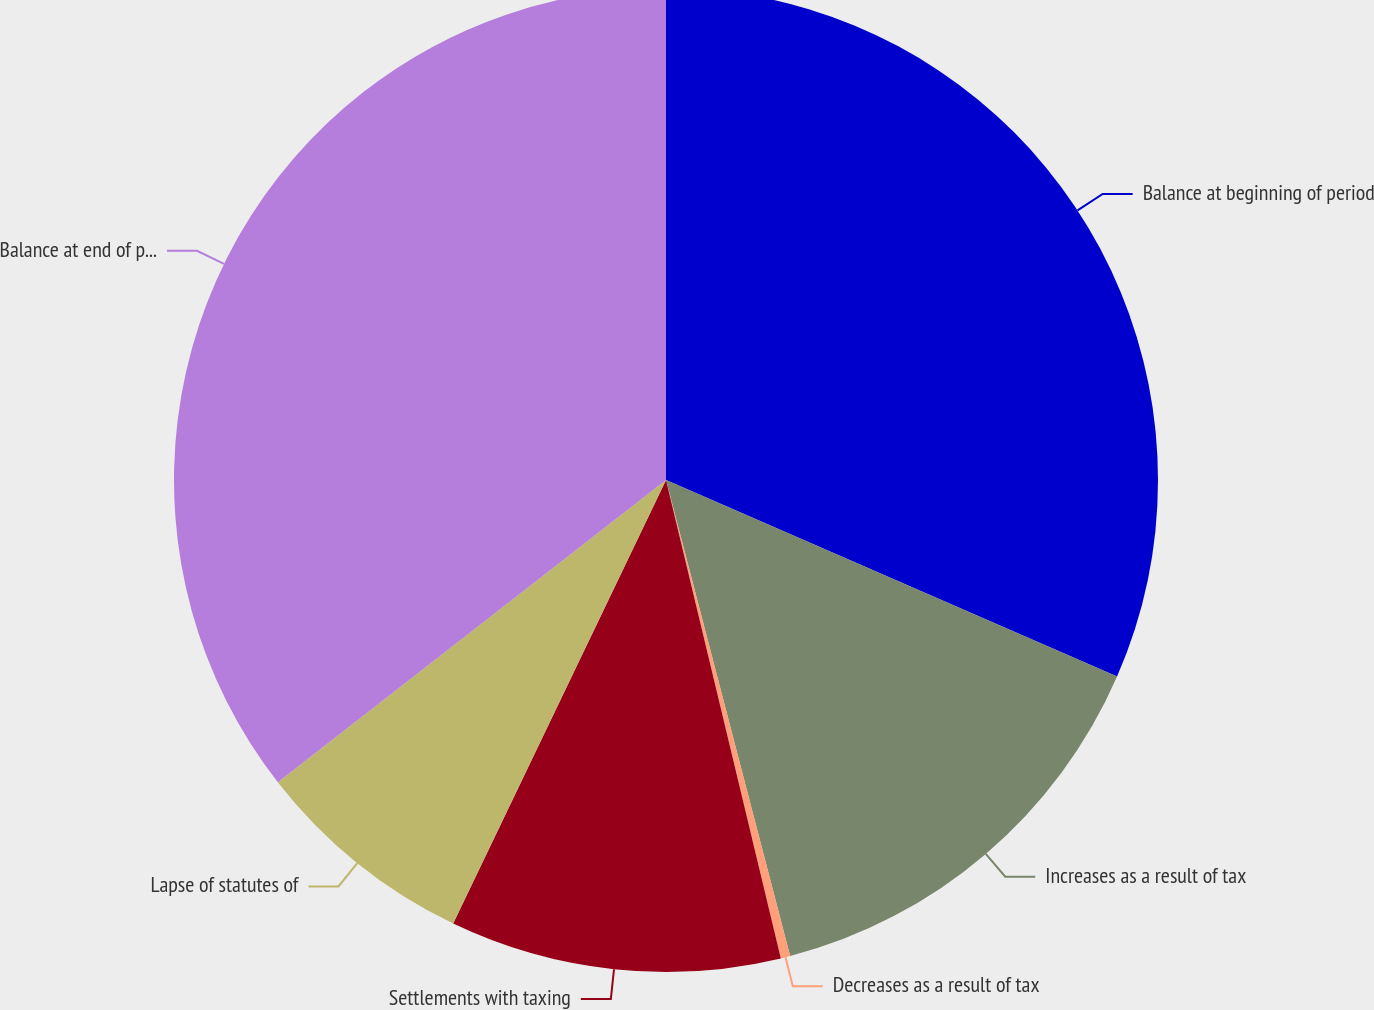<chart> <loc_0><loc_0><loc_500><loc_500><pie_chart><fcel>Balance at beginning of period<fcel>Increases as a result of tax<fcel>Decreases as a result of tax<fcel>Settlements with taxing<fcel>Lapse of statutes of<fcel>Balance at end of period<nl><fcel>31.54%<fcel>14.4%<fcel>0.31%<fcel>10.87%<fcel>7.35%<fcel>35.53%<nl></chart> 